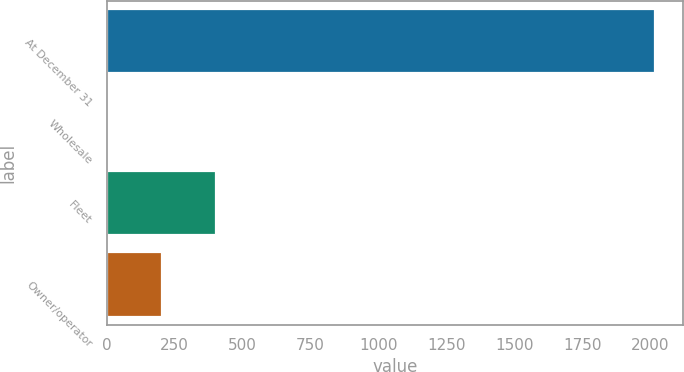<chart> <loc_0><loc_0><loc_500><loc_500><bar_chart><fcel>At December 31<fcel>Wholesale<fcel>Fleet<fcel>Owner/operator<nl><fcel>2018<fcel>0.1<fcel>403.68<fcel>201.89<nl></chart> 